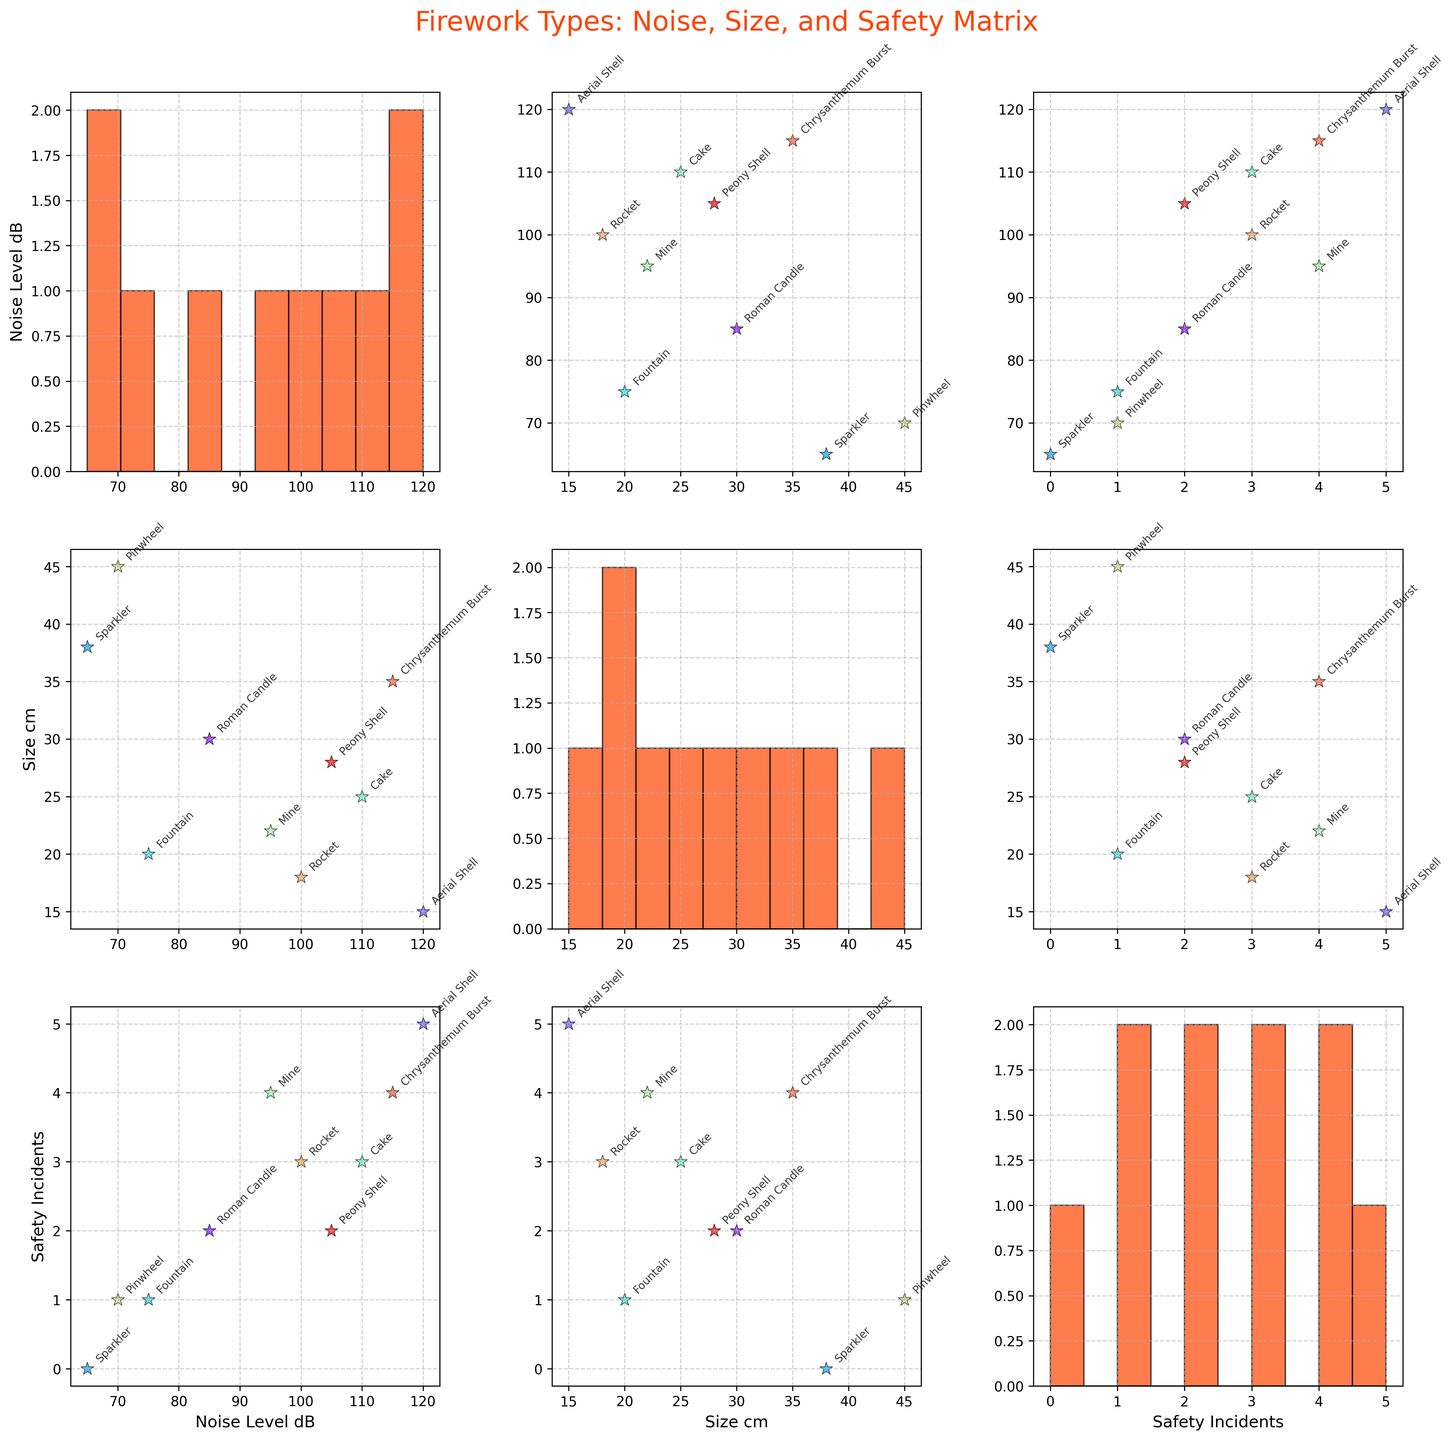What is the title of the figure? The title is located at the top of the figure, clearly indicating what the matrix is about. Simply read the text presented there.
Answer: Firework Types: Noise, Size, and Safety Matrix How many firework types are shown in the Scatter Plot Matrix? Each scatter point represents a particular firework type, and you can determine the number by either counting the labels or the individual scatter points in one of the plots.
Answer: 10 Which firework type has the highest noise level? Noise level can be observed on plots where 'Noise_Level_dB' is either on the x-axis or y-axis. Look for the highest point in those plots.
Answer: Aerial Shell Which firework type has the largest size? Size is represented by 'Size_cm'. In plots where 'Size_cm' appears, identify the point with the maximum value on the size axis and check its corresponding firework type.
Answer: Pinwheel What is the median size of the fireworks? To find the median size, you will need to order the 'Size_cm' values and find the middle value. With 10 data points, the median will be the average of the 5th and 6th values in the ordered list. Sizes: 15, 18, 20, 22, 25, 28, 30, 35, 38, 45. Median = (25 + 28)/2 = 26.5.
Answer: 26.5 Which firework has the most safety incidents, and what is the level? Safety incidents are shown on the axis representing 'Safety_Incidents'. Find the highest value on this axis, and then identify the corresponding firework type.
Answer: Aerial Shell, 5 Are there any fireworks that have zero safety incidents? If yes, which ones? Identify any points on the axes where 'Safety_Incidents' is 0. Points at this level indicate fireworks without incidents.
Answer: Sparkler How do Noise Levels and Safety Incidents correlate for Rocket? To figure out the correlation for Rocket, locate its position on the scatter plot where 'Noise_Level_dB' is plotted against 'Safety_Incidents', and note the values.
Answer: Noise Level: 100, Safety Incidents: 3 Compare the size of the Chrysanthemum Burst with the Peony Shell. Which is larger? Look at the size values for both the 'Chrysanthemum Burst' and 'Peony Shell' in the plots where 'Size_cm' is present.
Answer: Chrysanthemum Burst Which firework type appears to have the smallest size and what is its value? On plots where 'Size_cm' is an axis, look for the smallest point and its associated label.
Answer: Aerial Shell, 15 